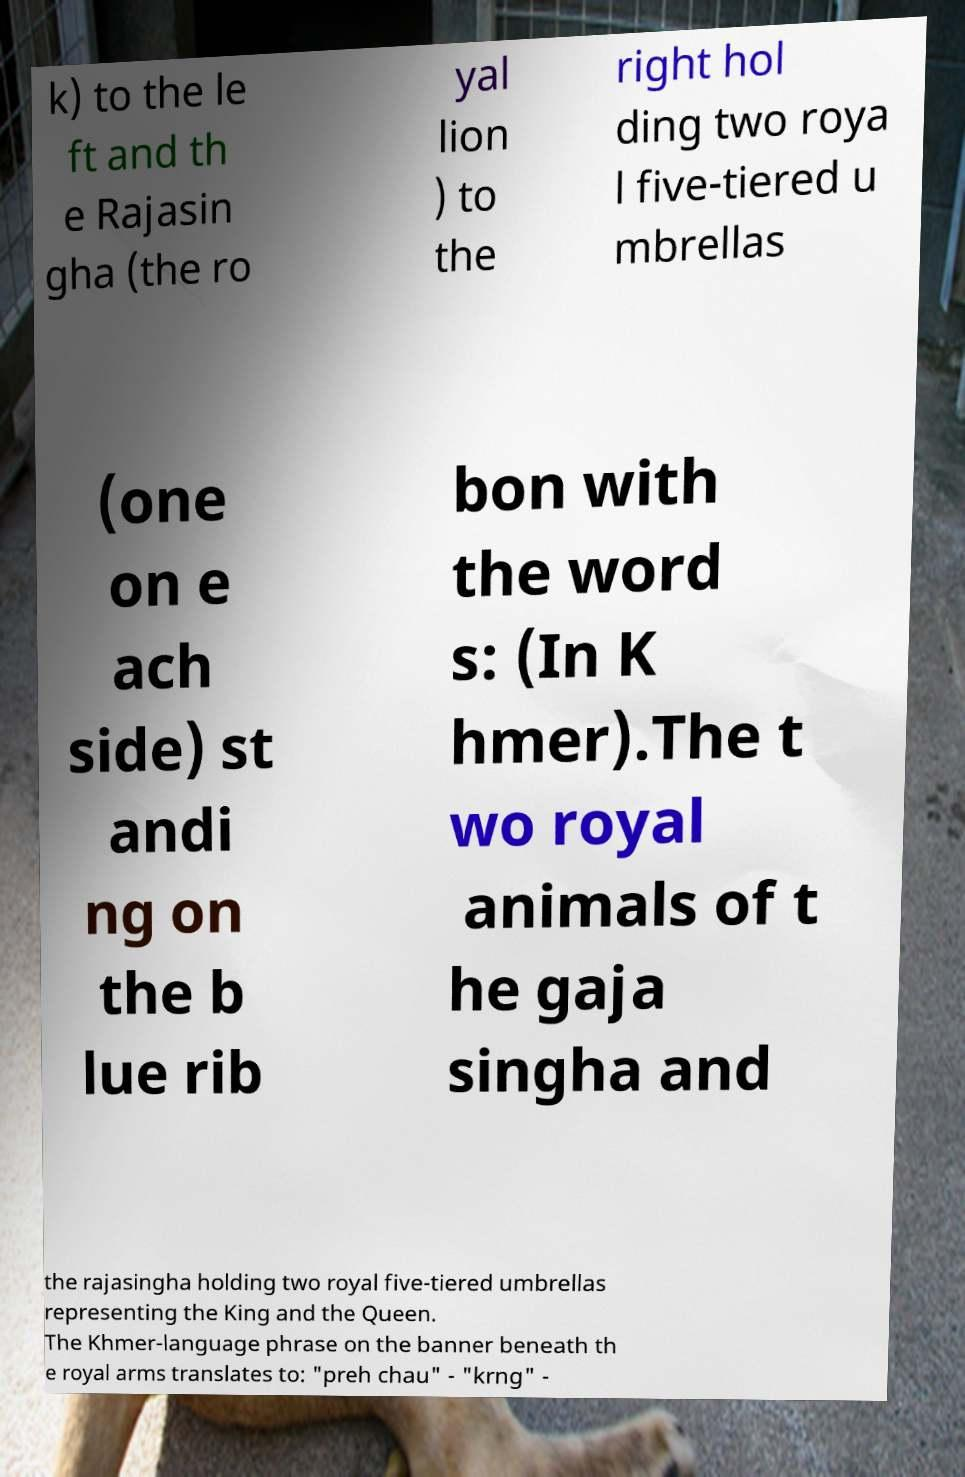Can you accurately transcribe the text from the provided image for me? k) to the le ft and th e Rajasin gha (the ro yal lion ) to the right hol ding two roya l five-tiered u mbrellas (one on e ach side) st andi ng on the b lue rib bon with the word s: (In K hmer).The t wo royal animals of t he gaja singha and the rajasingha holding two royal five-tiered umbrellas representing the King and the Queen. The Khmer-language phrase on the banner beneath th e royal arms translates to: "preh chau" - "krng" - 